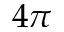Convert formula to latex. <formula><loc_0><loc_0><loc_500><loc_500>4 \pi</formula> 